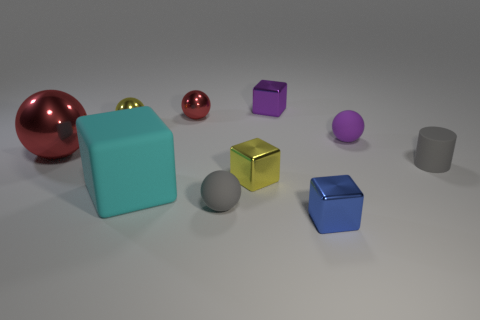Subtract all purple spheres. How many spheres are left? 4 Subtract all small cubes. How many cubes are left? 1 Subtract all blue balls. Subtract all yellow cubes. How many balls are left? 5 Subtract all blocks. How many objects are left? 6 Subtract all tiny purple rubber balls. Subtract all small gray things. How many objects are left? 7 Add 5 cylinders. How many cylinders are left? 6 Add 1 large yellow cubes. How many large yellow cubes exist? 1 Subtract 0 red cylinders. How many objects are left? 10 